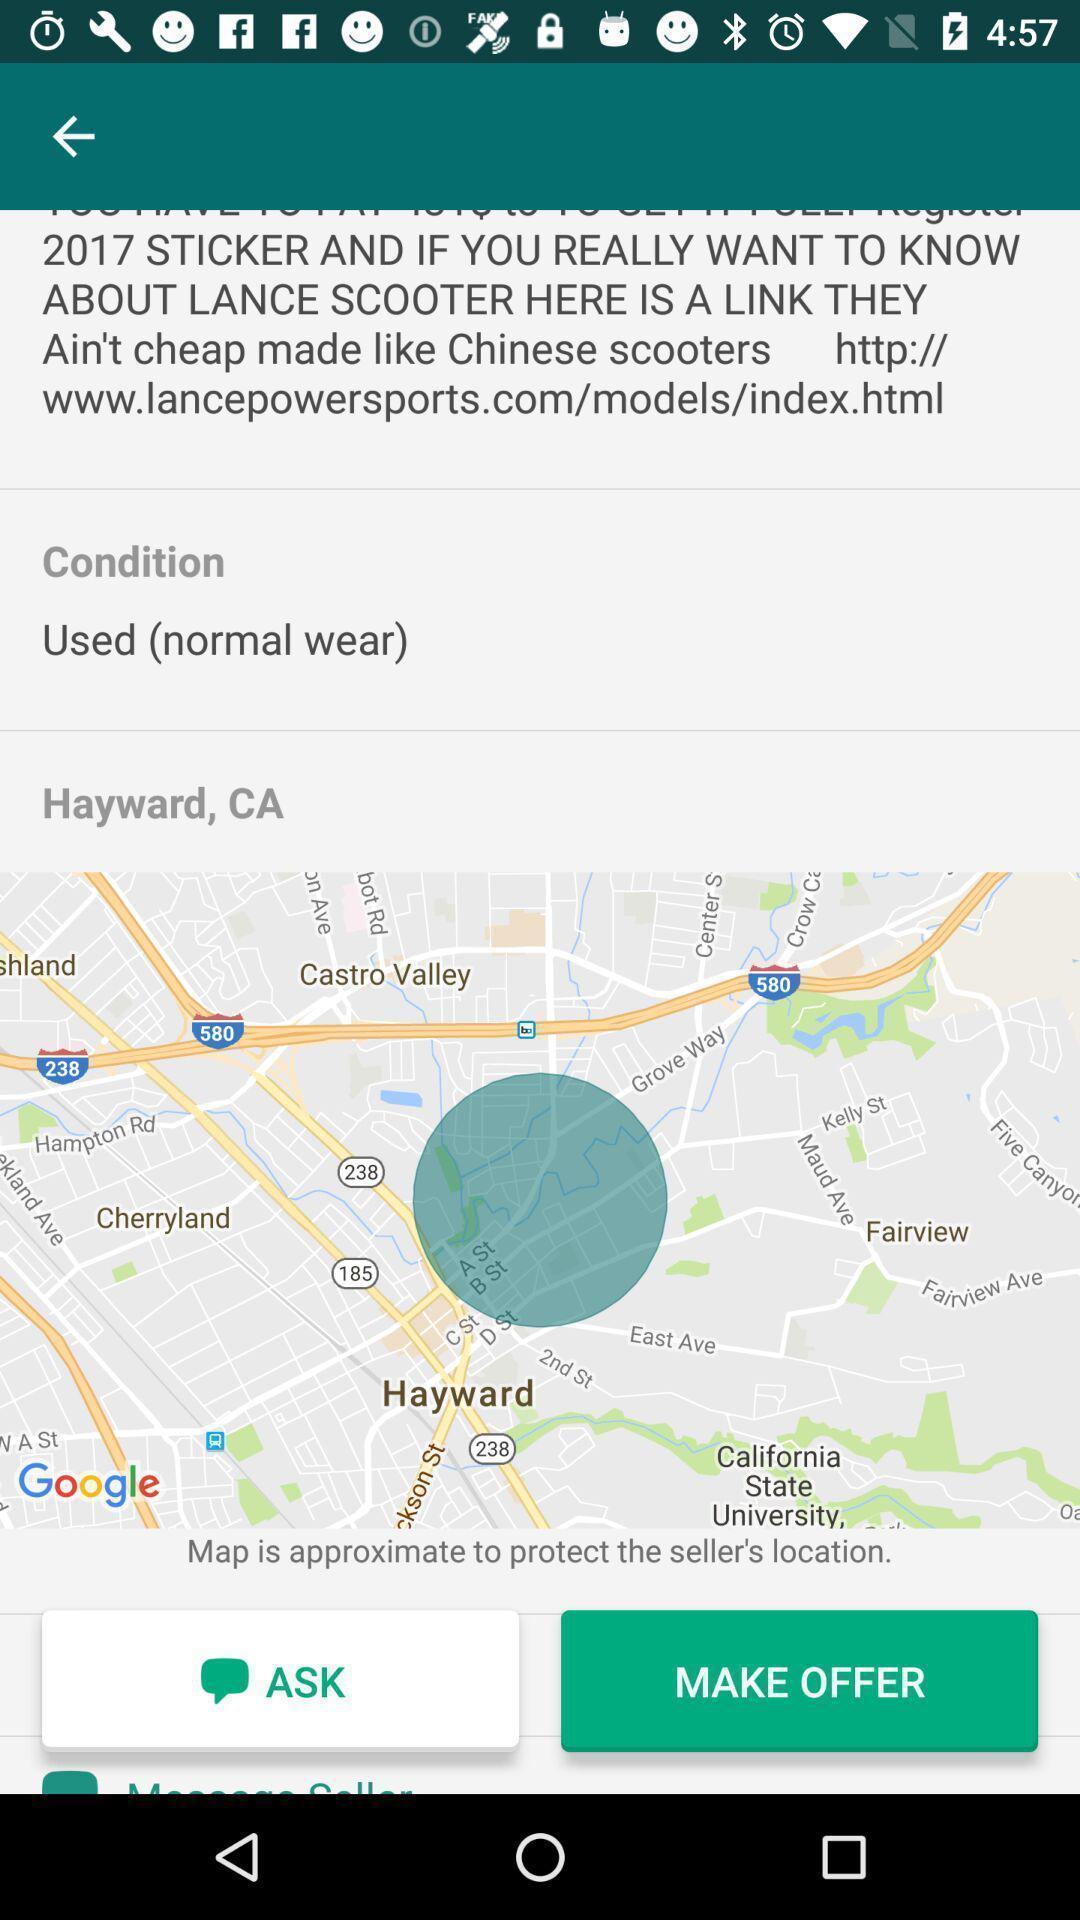Give me a narrative description of this picture. Page showing location in a navigation app. 